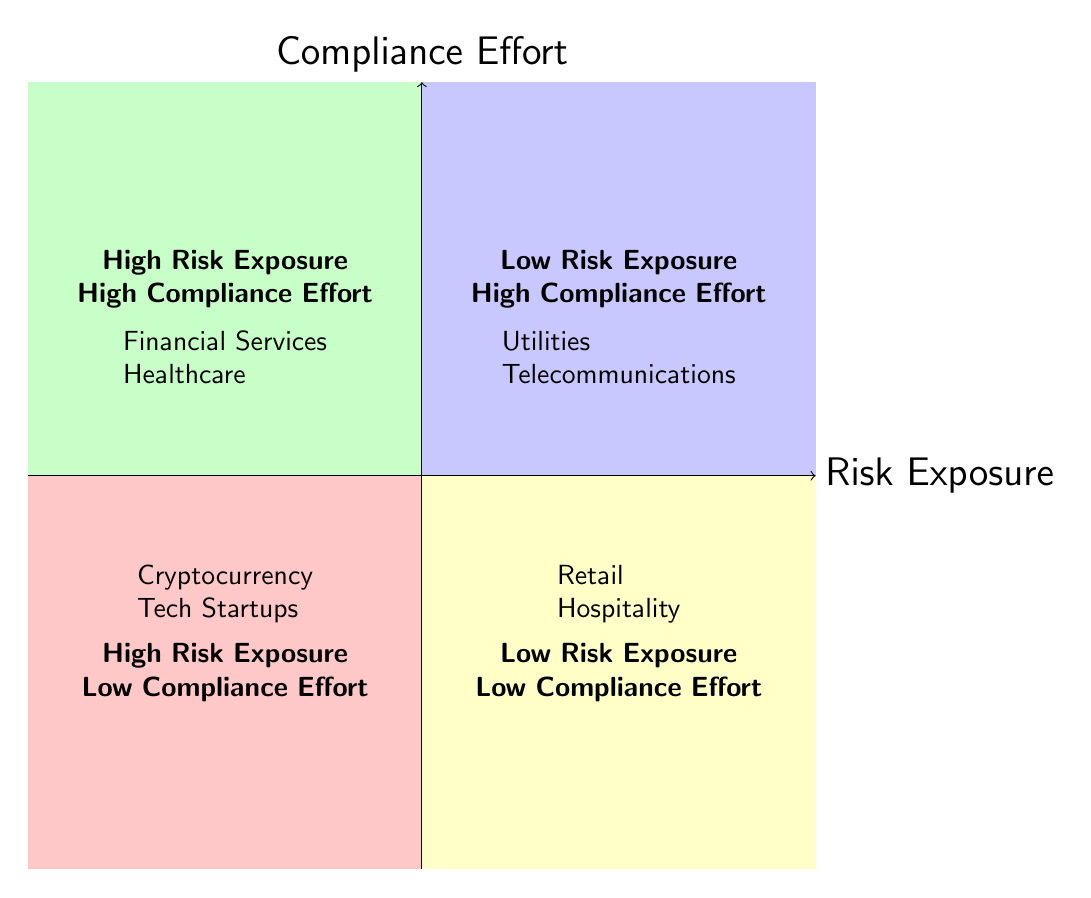What industries fall under High Risk Exposure - High Compliance Effort? In the High Risk Exposure - High Compliance Effort quadrant, the industries listed are Financial Services and Healthcare. These are explicitly mentioned in the diagram.
Answer: Financial Services, Healthcare How many industries are listed in the Low Risk Exposure - Low Compliance Effort quadrant? In the Low Risk Exposure - Low Compliance Effort quadrant, there are two industries mentioned: Retail and Hospitality. Thus, the total count is two.
Answer: 2 Which industry is represented as an example entity in the High Risk Exposure - Low Compliance Effort quadrant? In the High Risk Exposure - Low Compliance Effort quadrant, the example entities include Bitcoin Exchanges and Early-stage SaaS Companies. Focusing on the first one gives us Bitcoin Exchanges.
Answer: Bitcoin Exchanges What is the main risk factor for the Telecommunications industry? The risk factor listed for the Telecommunications industry is Customer Data Security. This can be found directly in the respective quadrant.
Answer: Customer Data Security Which quadrant has the entity 'Duke Energy'? The entity Duke Energy is found in the Low Risk Exposure - High Compliance Effort quadrant. This information is directly associated with the specific quadrants in the diagram.
Answer: Low Risk Exposure - High Compliance Effort Where would you classify the Tech Startups based on their risk exposure and compliance effort? Tech Startups are placed in the High Risk Exposure - Low Compliance Effort quadrant. This classification is based on the explicit mention of this industry and its characteristics in the diagram.
Answer: High Risk Exposure - Low Compliance Effort Which quadrant contains the highest compliance effort? The quadrants with High Compliance Effort are High Risk Exposure - High Compliance Effort and Low Risk Exposure - High Compliance Effort. Therefore, both quadrants exhibit the highest compliance focus.
Answer: High Risk Exposure - High Compliance Effort, Low Risk Exposure - High Compliance Effort What compliance aspects are associated with the Financial Services industry? The compliance aspects listed for the Financial Services industry are Anti-Money Laundering and Stress Testing. These are specifically outlined in the quadrant for that industry.
Answer: Anti-Money Laundering, Stress Testing Which quadrant highlights industries with the least compliance efforts? The quadrant that highlights industries with the least compliance efforts is the Low Risk Exposure - Low Compliance Effort quadrant, which includes industries with minimal requirements.
Answer: Low Risk Exposure - Low Compliance Effort 